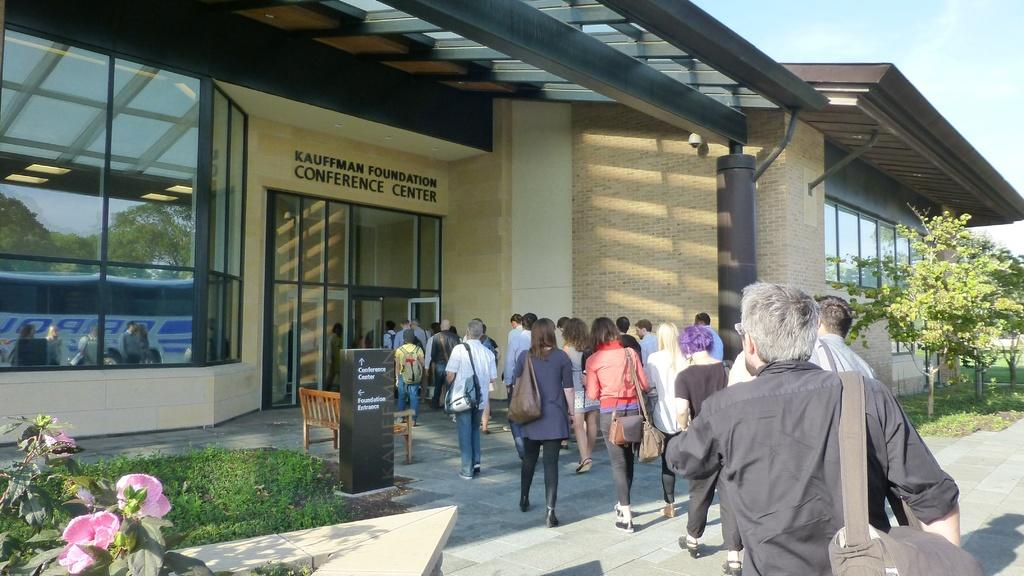What are the people in the image doing? The people in the image are walking. Where are the people walking to? The people are walking into a conference hall. What can be seen in front of the conference hall? There are trees and plants in front of the conference hall. What type of produce is being delivered to the conference hall in the image? There is no produce or delivery mentioned or visible in the image. 